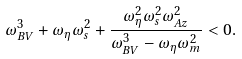Convert formula to latex. <formula><loc_0><loc_0><loc_500><loc_500>\omega _ { B V } ^ { 3 } + \omega _ { \eta } \omega _ { s } ^ { 2 } + \frac { \omega _ { \eta } ^ { 2 } \omega _ { s } ^ { 2 } \omega _ { A z } ^ { 2 } } { \omega _ { B V } ^ { 3 } - \omega _ { \eta } \omega _ { m } ^ { 2 } } < 0 .</formula> 